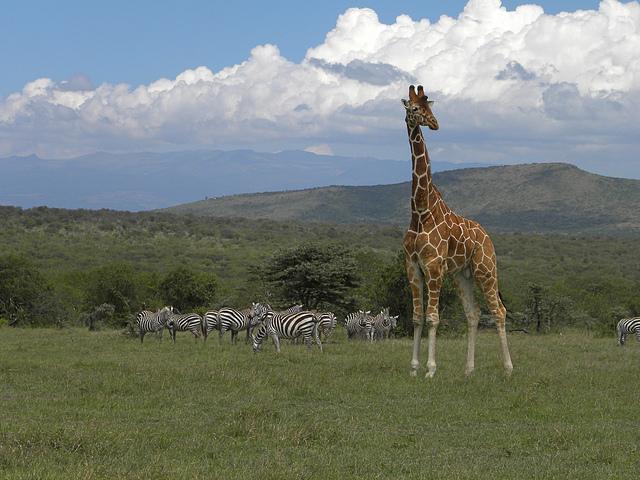How many giraffes are there?
Write a very short answer. 1. How many animals on the field?
Keep it brief. 10. Are there zebras in the picture?
Keep it brief. Yes. Are the giraffes eating the trees?
Be succinct. No. Is the giraffe going to cross the road?
Give a very brief answer. No. Is there a fence?
Keep it brief. No. Is this a zoo?
Concise answer only. No. What animal is with the zebras?
Keep it brief. Giraffe. Is there more than one type of animal in the scene?
Short answer required. Yes. How many animals are visible?
Short answer required. 12. Is the wind blowing?
Keep it brief. No. How many different animals are there?
Short answer required. 2. What is in the background?
Give a very brief answer. Zebras. 